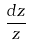<formula> <loc_0><loc_0><loc_500><loc_500>\frac { d z } { z }</formula> 